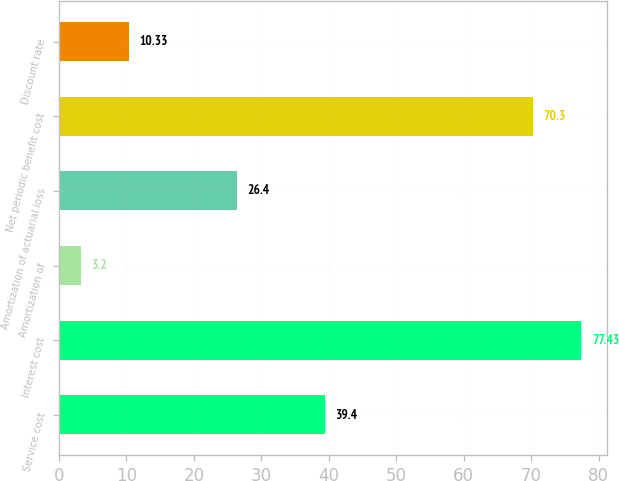Convert chart to OTSL. <chart><loc_0><loc_0><loc_500><loc_500><bar_chart><fcel>Service cost<fcel>Interest cost<fcel>Amortization of<fcel>Amortization of actuarial loss<fcel>Net periodic benefit cost<fcel>Discount rate<nl><fcel>39.4<fcel>77.43<fcel>3.2<fcel>26.4<fcel>70.3<fcel>10.33<nl></chart> 